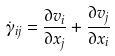Convert formula to latex. <formula><loc_0><loc_0><loc_500><loc_500>\dot { \gamma } _ { i j } = \frac { \partial v _ { i } } { \partial x _ { j } } + \frac { \partial v _ { j } } { \partial x _ { i } }</formula> 